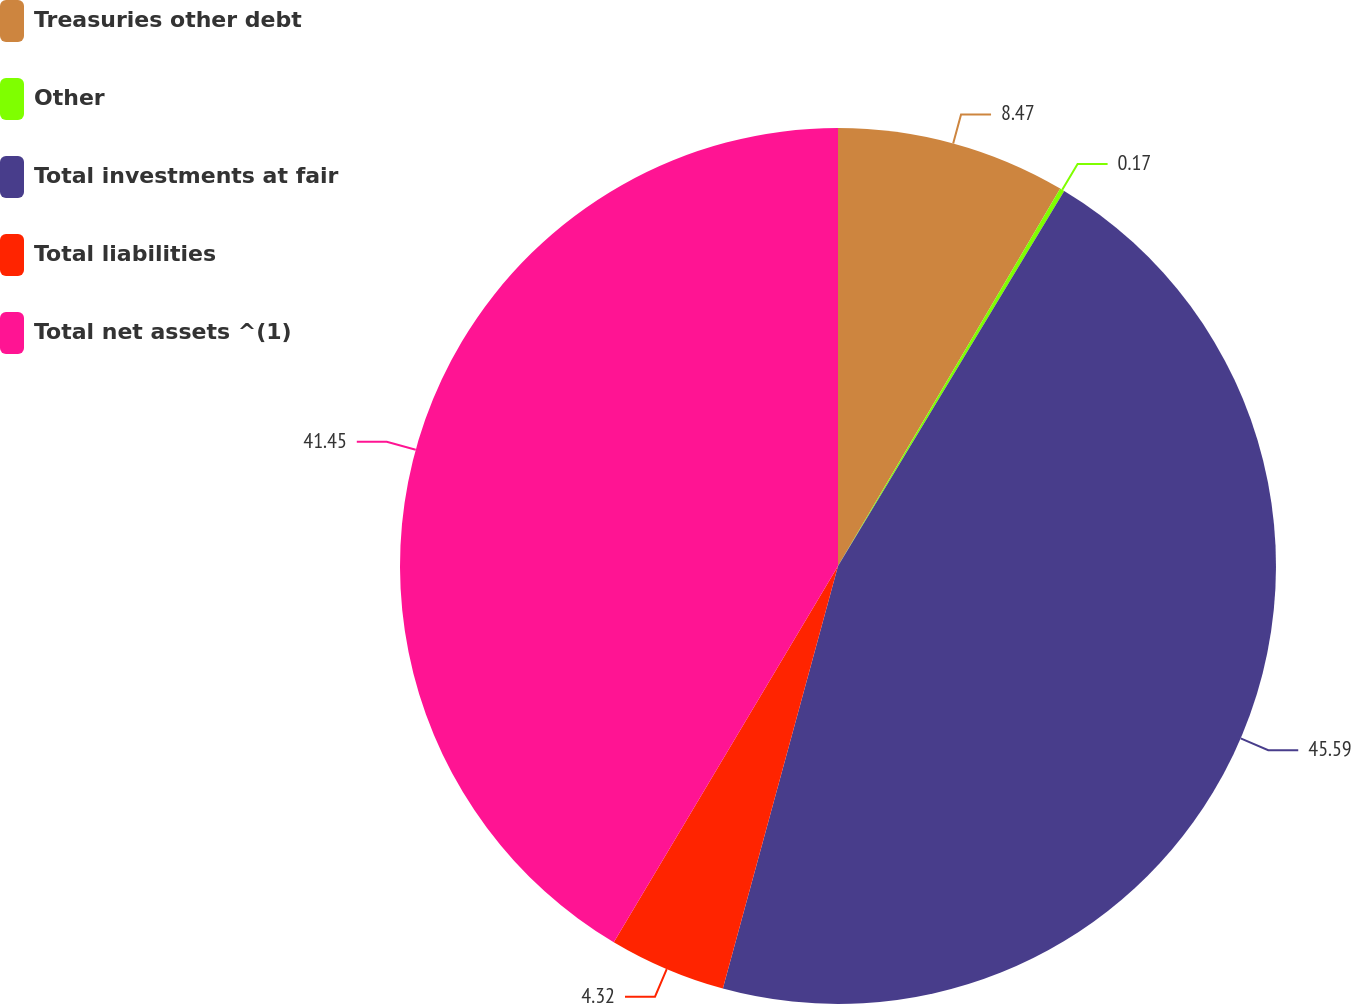Convert chart to OTSL. <chart><loc_0><loc_0><loc_500><loc_500><pie_chart><fcel>Treasuries other debt<fcel>Other<fcel>Total investments at fair<fcel>Total liabilities<fcel>Total net assets ^(1)<nl><fcel>8.47%<fcel>0.17%<fcel>45.6%<fcel>4.32%<fcel>41.45%<nl></chart> 